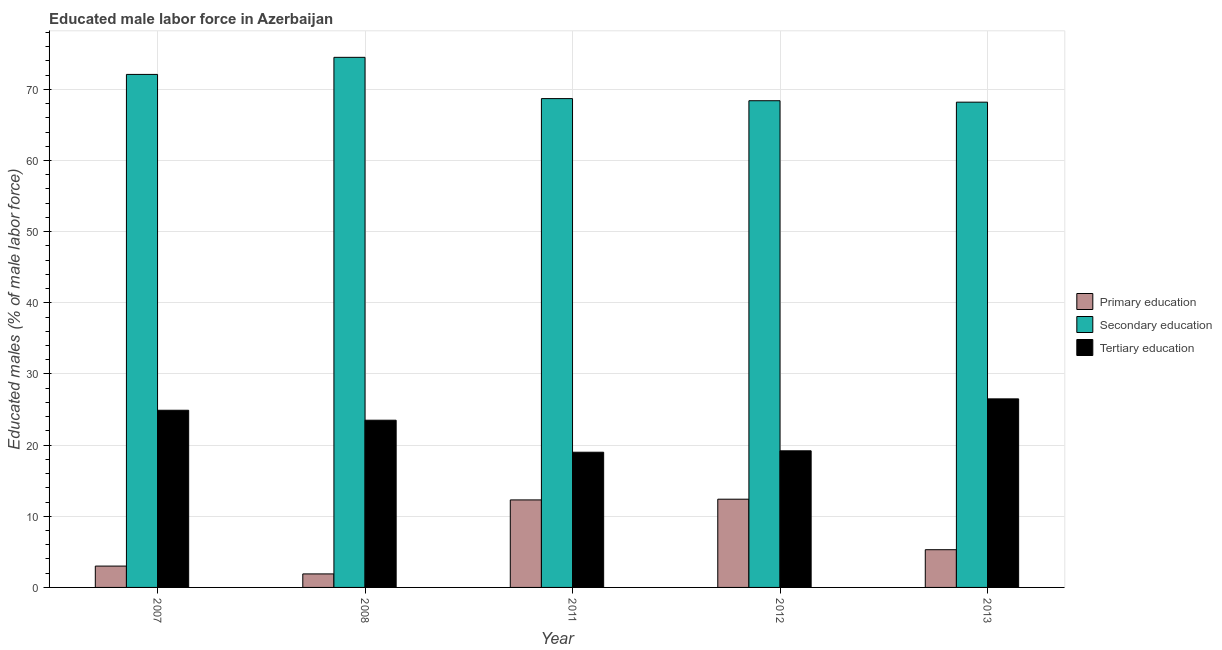How many groups of bars are there?
Keep it short and to the point. 5. Are the number of bars per tick equal to the number of legend labels?
Provide a short and direct response. Yes. Are the number of bars on each tick of the X-axis equal?
Offer a terse response. Yes. What is the label of the 1st group of bars from the left?
Ensure brevity in your answer.  2007. In how many cases, is the number of bars for a given year not equal to the number of legend labels?
Make the answer very short. 0. What is the percentage of male labor force who received secondary education in 2007?
Your response must be concise. 72.1. Across all years, what is the maximum percentage of male labor force who received tertiary education?
Ensure brevity in your answer.  26.5. Across all years, what is the minimum percentage of male labor force who received primary education?
Make the answer very short. 1.9. In which year was the percentage of male labor force who received primary education maximum?
Your answer should be compact. 2012. In which year was the percentage of male labor force who received tertiary education minimum?
Make the answer very short. 2011. What is the total percentage of male labor force who received secondary education in the graph?
Provide a short and direct response. 351.9. What is the difference between the percentage of male labor force who received primary education in 2012 and that in 2013?
Make the answer very short. 7.1. What is the difference between the percentage of male labor force who received tertiary education in 2013 and the percentage of male labor force who received primary education in 2012?
Keep it short and to the point. 7.3. What is the average percentage of male labor force who received tertiary education per year?
Your answer should be very brief. 22.62. In the year 2013, what is the difference between the percentage of male labor force who received secondary education and percentage of male labor force who received tertiary education?
Provide a succinct answer. 0. What is the ratio of the percentage of male labor force who received tertiary education in 2007 to that in 2008?
Offer a terse response. 1.06. What is the difference between the highest and the second highest percentage of male labor force who received tertiary education?
Your answer should be very brief. 1.6. What is the difference between the highest and the lowest percentage of male labor force who received primary education?
Make the answer very short. 10.5. What does the 3rd bar from the left in 2008 represents?
Offer a terse response. Tertiary education. What does the 2nd bar from the right in 2011 represents?
Offer a very short reply. Secondary education. Is it the case that in every year, the sum of the percentage of male labor force who received primary education and percentage of male labor force who received secondary education is greater than the percentage of male labor force who received tertiary education?
Offer a terse response. Yes. How many bars are there?
Keep it short and to the point. 15. Are all the bars in the graph horizontal?
Provide a short and direct response. No. Are the values on the major ticks of Y-axis written in scientific E-notation?
Provide a succinct answer. No. Does the graph contain any zero values?
Keep it short and to the point. No. Does the graph contain grids?
Keep it short and to the point. Yes. Where does the legend appear in the graph?
Your response must be concise. Center right. How are the legend labels stacked?
Provide a short and direct response. Vertical. What is the title of the graph?
Make the answer very short. Educated male labor force in Azerbaijan. What is the label or title of the X-axis?
Make the answer very short. Year. What is the label or title of the Y-axis?
Provide a succinct answer. Educated males (% of male labor force). What is the Educated males (% of male labor force) in Secondary education in 2007?
Offer a very short reply. 72.1. What is the Educated males (% of male labor force) in Tertiary education in 2007?
Provide a short and direct response. 24.9. What is the Educated males (% of male labor force) of Primary education in 2008?
Your answer should be compact. 1.9. What is the Educated males (% of male labor force) in Secondary education in 2008?
Make the answer very short. 74.5. What is the Educated males (% of male labor force) in Tertiary education in 2008?
Give a very brief answer. 23.5. What is the Educated males (% of male labor force) in Primary education in 2011?
Your response must be concise. 12.3. What is the Educated males (% of male labor force) of Secondary education in 2011?
Offer a very short reply. 68.7. What is the Educated males (% of male labor force) of Tertiary education in 2011?
Keep it short and to the point. 19. What is the Educated males (% of male labor force) of Primary education in 2012?
Provide a succinct answer. 12.4. What is the Educated males (% of male labor force) in Secondary education in 2012?
Offer a very short reply. 68.4. What is the Educated males (% of male labor force) in Tertiary education in 2012?
Ensure brevity in your answer.  19.2. What is the Educated males (% of male labor force) of Primary education in 2013?
Offer a terse response. 5.3. What is the Educated males (% of male labor force) in Secondary education in 2013?
Keep it short and to the point. 68.2. What is the Educated males (% of male labor force) in Tertiary education in 2013?
Your answer should be very brief. 26.5. Across all years, what is the maximum Educated males (% of male labor force) in Primary education?
Make the answer very short. 12.4. Across all years, what is the maximum Educated males (% of male labor force) in Secondary education?
Provide a short and direct response. 74.5. Across all years, what is the maximum Educated males (% of male labor force) of Tertiary education?
Ensure brevity in your answer.  26.5. Across all years, what is the minimum Educated males (% of male labor force) in Primary education?
Provide a succinct answer. 1.9. Across all years, what is the minimum Educated males (% of male labor force) of Secondary education?
Provide a succinct answer. 68.2. Across all years, what is the minimum Educated males (% of male labor force) in Tertiary education?
Provide a succinct answer. 19. What is the total Educated males (% of male labor force) in Primary education in the graph?
Keep it short and to the point. 34.9. What is the total Educated males (% of male labor force) of Secondary education in the graph?
Provide a succinct answer. 351.9. What is the total Educated males (% of male labor force) in Tertiary education in the graph?
Provide a short and direct response. 113.1. What is the difference between the Educated males (% of male labor force) of Primary education in 2007 and that in 2008?
Provide a succinct answer. 1.1. What is the difference between the Educated males (% of male labor force) in Tertiary education in 2007 and that in 2008?
Ensure brevity in your answer.  1.4. What is the difference between the Educated males (% of male labor force) in Tertiary education in 2007 and that in 2011?
Your answer should be compact. 5.9. What is the difference between the Educated males (% of male labor force) of Tertiary education in 2007 and that in 2012?
Your response must be concise. 5.7. What is the difference between the Educated males (% of male labor force) of Secondary education in 2007 and that in 2013?
Make the answer very short. 3.9. What is the difference between the Educated males (% of male labor force) in Tertiary education in 2007 and that in 2013?
Provide a succinct answer. -1.6. What is the difference between the Educated males (% of male labor force) in Primary education in 2008 and that in 2011?
Offer a very short reply. -10.4. What is the difference between the Educated males (% of male labor force) of Secondary education in 2008 and that in 2011?
Your answer should be compact. 5.8. What is the difference between the Educated males (% of male labor force) of Primary education in 2008 and that in 2012?
Give a very brief answer. -10.5. What is the difference between the Educated males (% of male labor force) in Secondary education in 2008 and that in 2012?
Your response must be concise. 6.1. What is the difference between the Educated males (% of male labor force) in Secondary education in 2008 and that in 2013?
Provide a succinct answer. 6.3. What is the difference between the Educated males (% of male labor force) in Secondary education in 2011 and that in 2012?
Keep it short and to the point. 0.3. What is the difference between the Educated males (% of male labor force) of Tertiary education in 2011 and that in 2012?
Offer a very short reply. -0.2. What is the difference between the Educated males (% of male labor force) in Primary education in 2011 and that in 2013?
Offer a very short reply. 7. What is the difference between the Educated males (% of male labor force) in Secondary education in 2011 and that in 2013?
Your response must be concise. 0.5. What is the difference between the Educated males (% of male labor force) in Tertiary education in 2011 and that in 2013?
Offer a very short reply. -7.5. What is the difference between the Educated males (% of male labor force) of Secondary education in 2012 and that in 2013?
Provide a short and direct response. 0.2. What is the difference between the Educated males (% of male labor force) in Primary education in 2007 and the Educated males (% of male labor force) in Secondary education in 2008?
Offer a very short reply. -71.5. What is the difference between the Educated males (% of male labor force) of Primary education in 2007 and the Educated males (% of male labor force) of Tertiary education in 2008?
Provide a short and direct response. -20.5. What is the difference between the Educated males (% of male labor force) of Secondary education in 2007 and the Educated males (% of male labor force) of Tertiary education in 2008?
Give a very brief answer. 48.6. What is the difference between the Educated males (% of male labor force) of Primary education in 2007 and the Educated males (% of male labor force) of Secondary education in 2011?
Your answer should be very brief. -65.7. What is the difference between the Educated males (% of male labor force) in Secondary education in 2007 and the Educated males (% of male labor force) in Tertiary education in 2011?
Give a very brief answer. 53.1. What is the difference between the Educated males (% of male labor force) in Primary education in 2007 and the Educated males (% of male labor force) in Secondary education in 2012?
Make the answer very short. -65.4. What is the difference between the Educated males (% of male labor force) of Primary education in 2007 and the Educated males (% of male labor force) of Tertiary education in 2012?
Make the answer very short. -16.2. What is the difference between the Educated males (% of male labor force) of Secondary education in 2007 and the Educated males (% of male labor force) of Tertiary education in 2012?
Provide a succinct answer. 52.9. What is the difference between the Educated males (% of male labor force) of Primary education in 2007 and the Educated males (% of male labor force) of Secondary education in 2013?
Keep it short and to the point. -65.2. What is the difference between the Educated males (% of male labor force) of Primary education in 2007 and the Educated males (% of male labor force) of Tertiary education in 2013?
Your response must be concise. -23.5. What is the difference between the Educated males (% of male labor force) in Secondary education in 2007 and the Educated males (% of male labor force) in Tertiary education in 2013?
Offer a terse response. 45.6. What is the difference between the Educated males (% of male labor force) in Primary education in 2008 and the Educated males (% of male labor force) in Secondary education in 2011?
Make the answer very short. -66.8. What is the difference between the Educated males (% of male labor force) in Primary education in 2008 and the Educated males (% of male labor force) in Tertiary education in 2011?
Your answer should be very brief. -17.1. What is the difference between the Educated males (% of male labor force) in Secondary education in 2008 and the Educated males (% of male labor force) in Tertiary education in 2011?
Keep it short and to the point. 55.5. What is the difference between the Educated males (% of male labor force) of Primary education in 2008 and the Educated males (% of male labor force) of Secondary education in 2012?
Offer a very short reply. -66.5. What is the difference between the Educated males (% of male labor force) in Primary education in 2008 and the Educated males (% of male labor force) in Tertiary education in 2012?
Keep it short and to the point. -17.3. What is the difference between the Educated males (% of male labor force) in Secondary education in 2008 and the Educated males (% of male labor force) in Tertiary education in 2012?
Your answer should be very brief. 55.3. What is the difference between the Educated males (% of male labor force) of Primary education in 2008 and the Educated males (% of male labor force) of Secondary education in 2013?
Offer a terse response. -66.3. What is the difference between the Educated males (% of male labor force) of Primary education in 2008 and the Educated males (% of male labor force) of Tertiary education in 2013?
Your response must be concise. -24.6. What is the difference between the Educated males (% of male labor force) in Primary education in 2011 and the Educated males (% of male labor force) in Secondary education in 2012?
Make the answer very short. -56.1. What is the difference between the Educated males (% of male labor force) of Primary education in 2011 and the Educated males (% of male labor force) of Tertiary education in 2012?
Ensure brevity in your answer.  -6.9. What is the difference between the Educated males (% of male labor force) in Secondary education in 2011 and the Educated males (% of male labor force) in Tertiary education in 2012?
Your answer should be compact. 49.5. What is the difference between the Educated males (% of male labor force) of Primary education in 2011 and the Educated males (% of male labor force) of Secondary education in 2013?
Make the answer very short. -55.9. What is the difference between the Educated males (% of male labor force) of Secondary education in 2011 and the Educated males (% of male labor force) of Tertiary education in 2013?
Your response must be concise. 42.2. What is the difference between the Educated males (% of male labor force) in Primary education in 2012 and the Educated males (% of male labor force) in Secondary education in 2013?
Provide a short and direct response. -55.8. What is the difference between the Educated males (% of male labor force) in Primary education in 2012 and the Educated males (% of male labor force) in Tertiary education in 2013?
Keep it short and to the point. -14.1. What is the difference between the Educated males (% of male labor force) of Secondary education in 2012 and the Educated males (% of male labor force) of Tertiary education in 2013?
Your response must be concise. 41.9. What is the average Educated males (% of male labor force) in Primary education per year?
Make the answer very short. 6.98. What is the average Educated males (% of male labor force) of Secondary education per year?
Provide a succinct answer. 70.38. What is the average Educated males (% of male labor force) in Tertiary education per year?
Your response must be concise. 22.62. In the year 2007, what is the difference between the Educated males (% of male labor force) in Primary education and Educated males (% of male labor force) in Secondary education?
Provide a succinct answer. -69.1. In the year 2007, what is the difference between the Educated males (% of male labor force) in Primary education and Educated males (% of male labor force) in Tertiary education?
Offer a terse response. -21.9. In the year 2007, what is the difference between the Educated males (% of male labor force) of Secondary education and Educated males (% of male labor force) of Tertiary education?
Make the answer very short. 47.2. In the year 2008, what is the difference between the Educated males (% of male labor force) in Primary education and Educated males (% of male labor force) in Secondary education?
Keep it short and to the point. -72.6. In the year 2008, what is the difference between the Educated males (% of male labor force) of Primary education and Educated males (% of male labor force) of Tertiary education?
Provide a succinct answer. -21.6. In the year 2011, what is the difference between the Educated males (% of male labor force) in Primary education and Educated males (% of male labor force) in Secondary education?
Provide a short and direct response. -56.4. In the year 2011, what is the difference between the Educated males (% of male labor force) in Primary education and Educated males (% of male labor force) in Tertiary education?
Keep it short and to the point. -6.7. In the year 2011, what is the difference between the Educated males (% of male labor force) in Secondary education and Educated males (% of male labor force) in Tertiary education?
Keep it short and to the point. 49.7. In the year 2012, what is the difference between the Educated males (% of male labor force) in Primary education and Educated males (% of male labor force) in Secondary education?
Provide a succinct answer. -56. In the year 2012, what is the difference between the Educated males (% of male labor force) in Primary education and Educated males (% of male labor force) in Tertiary education?
Offer a very short reply. -6.8. In the year 2012, what is the difference between the Educated males (% of male labor force) of Secondary education and Educated males (% of male labor force) of Tertiary education?
Offer a very short reply. 49.2. In the year 2013, what is the difference between the Educated males (% of male labor force) of Primary education and Educated males (% of male labor force) of Secondary education?
Offer a very short reply. -62.9. In the year 2013, what is the difference between the Educated males (% of male labor force) of Primary education and Educated males (% of male labor force) of Tertiary education?
Your response must be concise. -21.2. In the year 2013, what is the difference between the Educated males (% of male labor force) in Secondary education and Educated males (% of male labor force) in Tertiary education?
Your answer should be compact. 41.7. What is the ratio of the Educated males (% of male labor force) of Primary education in 2007 to that in 2008?
Your answer should be compact. 1.58. What is the ratio of the Educated males (% of male labor force) in Secondary education in 2007 to that in 2008?
Ensure brevity in your answer.  0.97. What is the ratio of the Educated males (% of male labor force) of Tertiary education in 2007 to that in 2008?
Keep it short and to the point. 1.06. What is the ratio of the Educated males (% of male labor force) of Primary education in 2007 to that in 2011?
Provide a short and direct response. 0.24. What is the ratio of the Educated males (% of male labor force) of Secondary education in 2007 to that in 2011?
Provide a short and direct response. 1.05. What is the ratio of the Educated males (% of male labor force) in Tertiary education in 2007 to that in 2011?
Offer a terse response. 1.31. What is the ratio of the Educated males (% of male labor force) of Primary education in 2007 to that in 2012?
Keep it short and to the point. 0.24. What is the ratio of the Educated males (% of male labor force) of Secondary education in 2007 to that in 2012?
Your answer should be compact. 1.05. What is the ratio of the Educated males (% of male labor force) of Tertiary education in 2007 to that in 2012?
Give a very brief answer. 1.3. What is the ratio of the Educated males (% of male labor force) of Primary education in 2007 to that in 2013?
Your answer should be compact. 0.57. What is the ratio of the Educated males (% of male labor force) in Secondary education in 2007 to that in 2013?
Offer a very short reply. 1.06. What is the ratio of the Educated males (% of male labor force) in Tertiary education in 2007 to that in 2013?
Make the answer very short. 0.94. What is the ratio of the Educated males (% of male labor force) in Primary education in 2008 to that in 2011?
Ensure brevity in your answer.  0.15. What is the ratio of the Educated males (% of male labor force) of Secondary education in 2008 to that in 2011?
Offer a very short reply. 1.08. What is the ratio of the Educated males (% of male labor force) of Tertiary education in 2008 to that in 2011?
Your answer should be compact. 1.24. What is the ratio of the Educated males (% of male labor force) of Primary education in 2008 to that in 2012?
Ensure brevity in your answer.  0.15. What is the ratio of the Educated males (% of male labor force) of Secondary education in 2008 to that in 2012?
Keep it short and to the point. 1.09. What is the ratio of the Educated males (% of male labor force) in Tertiary education in 2008 to that in 2012?
Your answer should be compact. 1.22. What is the ratio of the Educated males (% of male labor force) of Primary education in 2008 to that in 2013?
Offer a terse response. 0.36. What is the ratio of the Educated males (% of male labor force) in Secondary education in 2008 to that in 2013?
Ensure brevity in your answer.  1.09. What is the ratio of the Educated males (% of male labor force) in Tertiary education in 2008 to that in 2013?
Provide a succinct answer. 0.89. What is the ratio of the Educated males (% of male labor force) in Primary education in 2011 to that in 2012?
Provide a short and direct response. 0.99. What is the ratio of the Educated males (% of male labor force) in Tertiary education in 2011 to that in 2012?
Ensure brevity in your answer.  0.99. What is the ratio of the Educated males (% of male labor force) of Primary education in 2011 to that in 2013?
Keep it short and to the point. 2.32. What is the ratio of the Educated males (% of male labor force) of Secondary education in 2011 to that in 2013?
Ensure brevity in your answer.  1.01. What is the ratio of the Educated males (% of male labor force) in Tertiary education in 2011 to that in 2013?
Make the answer very short. 0.72. What is the ratio of the Educated males (% of male labor force) in Primary education in 2012 to that in 2013?
Provide a short and direct response. 2.34. What is the ratio of the Educated males (% of male labor force) in Tertiary education in 2012 to that in 2013?
Offer a terse response. 0.72. What is the difference between the highest and the second highest Educated males (% of male labor force) in Primary education?
Offer a very short reply. 0.1. What is the difference between the highest and the second highest Educated males (% of male labor force) of Secondary education?
Give a very brief answer. 2.4. What is the difference between the highest and the second highest Educated males (% of male labor force) of Tertiary education?
Make the answer very short. 1.6. What is the difference between the highest and the lowest Educated males (% of male labor force) in Tertiary education?
Your answer should be very brief. 7.5. 